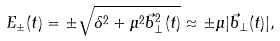Convert formula to latex. <formula><loc_0><loc_0><loc_500><loc_500>E _ { \pm } ( t ) = \pm \sqrt { \delta ^ { 2 } + \mu ^ { 2 } { \vec { b } _ { \perp } } ^ { 2 } ( t ) } \approx \pm \mu | { \vec { b } _ { \perp } } ( t ) | ,</formula> 